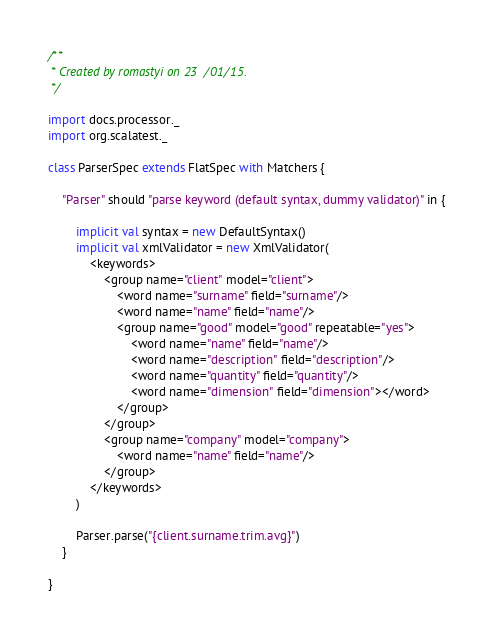<code> <loc_0><loc_0><loc_500><loc_500><_Scala_>/**
 * Created by romastyi on 23/01/15.
 */

import docs.processor._
import org.scalatest._

class ParserSpec extends FlatSpec with Matchers {

    "Parser" should "parse keyword (default syntax, dummy validator)" in {

        implicit val syntax = new DefaultSyntax()
        implicit val xmlValidator = new XmlValidator(
            <keywords>
                <group name="client" model="client">
                    <word name="surname" field="surname"/>
                    <word name="name" field="name"/>
                    <group name="good" model="good" repeatable="yes">
                        <word name="name" field="name"/>
                        <word name="description" field="description"/>
                        <word name="quantity" field="quantity"/>
                        <word name="dimension" field="dimension"></word>
                    </group>
                </group>
                <group name="company" model="company">
                    <word name="name" field="name"/>
                </group>
            </keywords>
        )

        Parser.parse("{client.surname.trim.avg}")
    }

}
</code> 